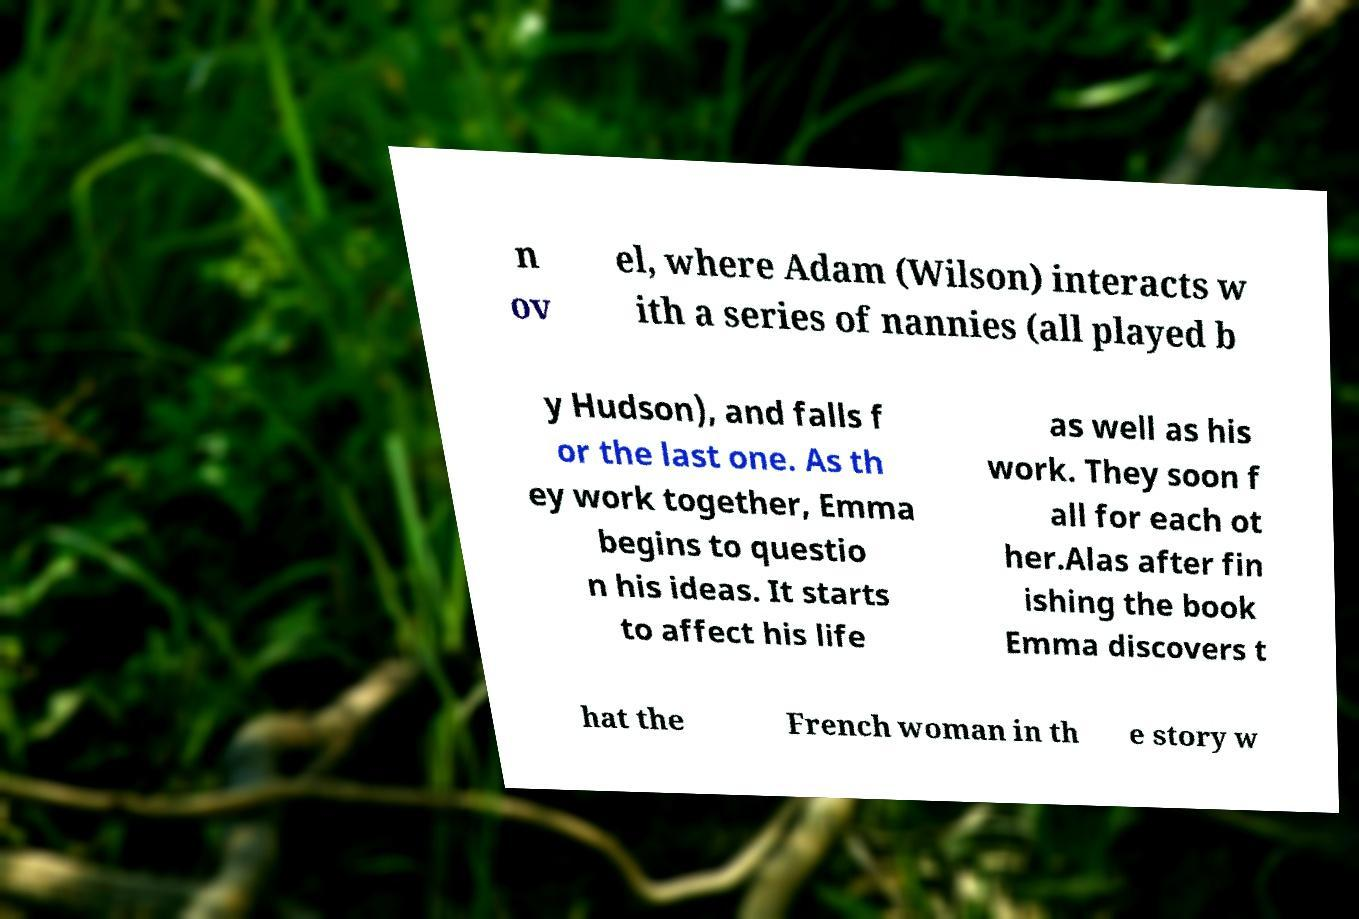There's text embedded in this image that I need extracted. Can you transcribe it verbatim? n ov el, where Adam (Wilson) interacts w ith a series of nannies (all played b y Hudson), and falls f or the last one. As th ey work together, Emma begins to questio n his ideas. It starts to affect his life as well as his work. They soon f all for each ot her.Alas after fin ishing the book Emma discovers t hat the French woman in th e story w 